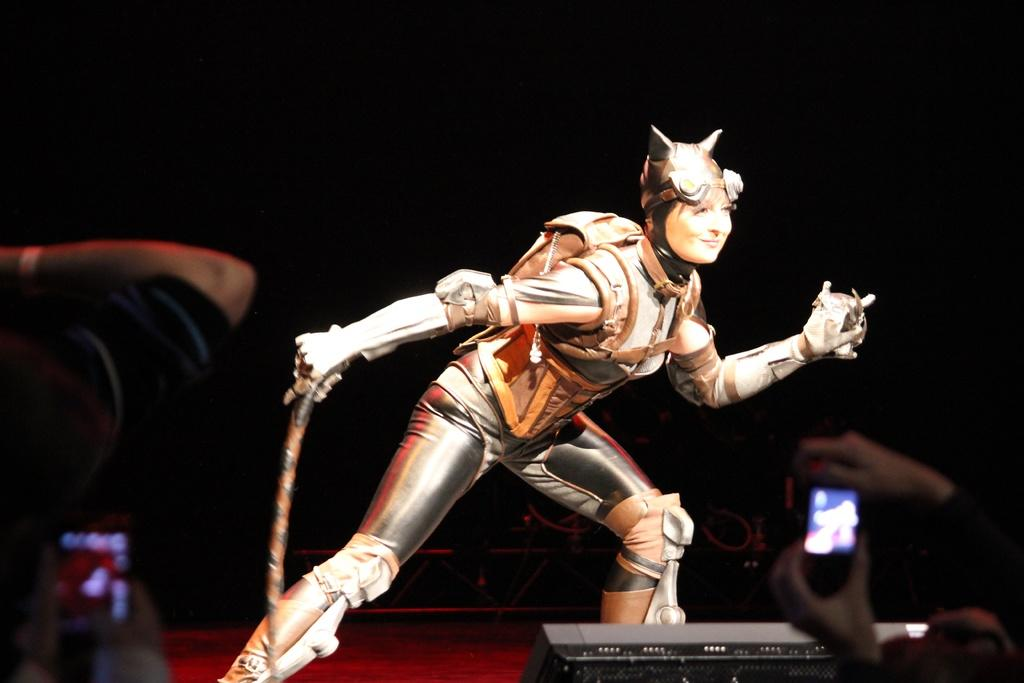Who is present in the image? There is a woman in the image. What is the woman holding? The woman is holding a weapon. What is the facial expression of the woman? The woman is smiling. How many people are in the image? There are two persons in the image. What are the two persons holding? The two persons are holding mobile phones. What can be observed about the background of the image? The background of the image is dark. Can you see a trail leading to the sea in the image? There is no trail or sea visible in the image. 